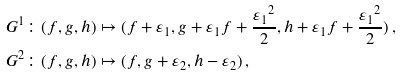<formula> <loc_0><loc_0><loc_500><loc_500>G ^ { 1 } & \colon ( f , g , h ) \mapsto ( f + \varepsilon _ { 1 } , g + \varepsilon _ { 1 } f + \frac { { \varepsilon _ { 1 } } ^ { 2 } } { 2 } , h + \varepsilon _ { 1 } f + \frac { { \varepsilon _ { 1 } } ^ { 2 } } { 2 } ) \, , \\ G ^ { 2 } & \colon ( f , g , h ) \mapsto ( f , g + \varepsilon _ { 2 } , h - \varepsilon _ { 2 } ) \, ,</formula> 